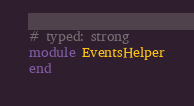<code> <loc_0><loc_0><loc_500><loc_500><_Ruby_># typed: strong
module EventsHelper
end
</code> 